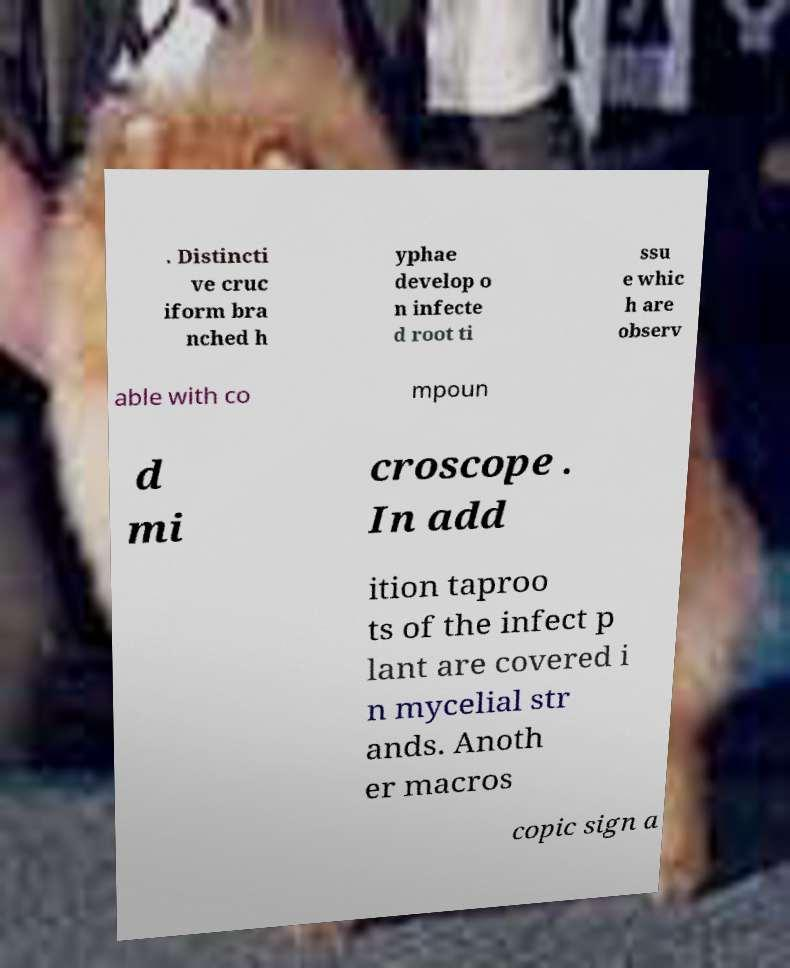Can you accurately transcribe the text from the provided image for me? . Distincti ve cruc iform bra nched h yphae develop o n infecte d root ti ssu e whic h are observ able with co mpoun d mi croscope . In add ition taproo ts of the infect p lant are covered i n mycelial str ands. Anoth er macros copic sign a 